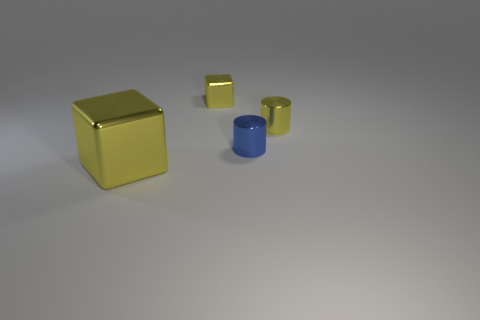Add 4 big yellow things. How many objects exist? 8 Subtract all tiny shiny cubes. Subtract all large yellow cubes. How many objects are left? 2 Add 2 small yellow metallic blocks. How many small yellow metallic blocks are left? 3 Add 4 cylinders. How many cylinders exist? 6 Subtract 0 brown cylinders. How many objects are left? 4 